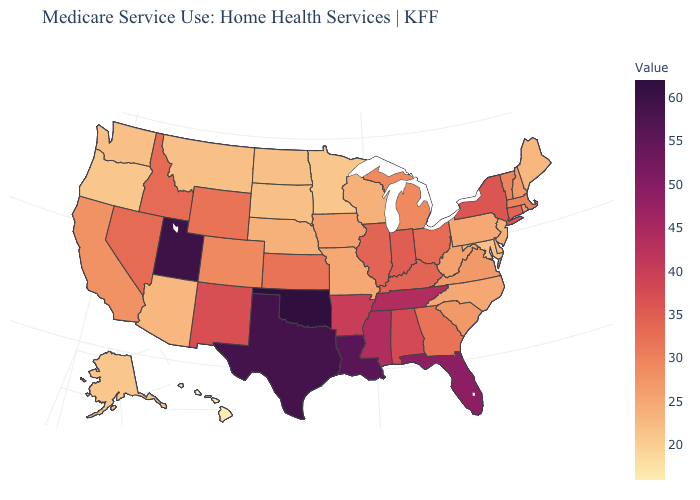Does Oklahoma have the highest value in the USA?
Write a very short answer. Yes. Does Pennsylvania have the highest value in the USA?
Concise answer only. No. Does Oklahoma have the highest value in the USA?
Quick response, please. Yes. Which states have the lowest value in the West?
Short answer required. Hawaii. Which states hav the highest value in the Northeast?
Answer briefly. New York. Which states have the lowest value in the West?
Quick response, please. Hawaii. Does Kentucky have the highest value in the South?
Concise answer only. No. 